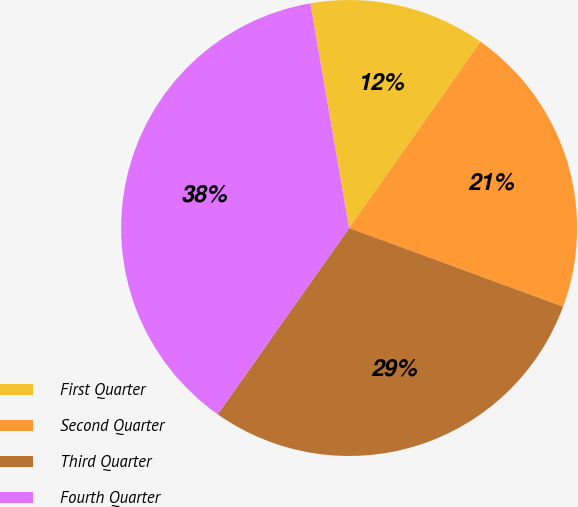Convert chart to OTSL. <chart><loc_0><loc_0><loc_500><loc_500><pie_chart><fcel>First Quarter<fcel>Second Quarter<fcel>Third Quarter<fcel>Fourth Quarter<nl><fcel>12.5%<fcel>20.83%<fcel>29.17%<fcel>37.5%<nl></chart> 